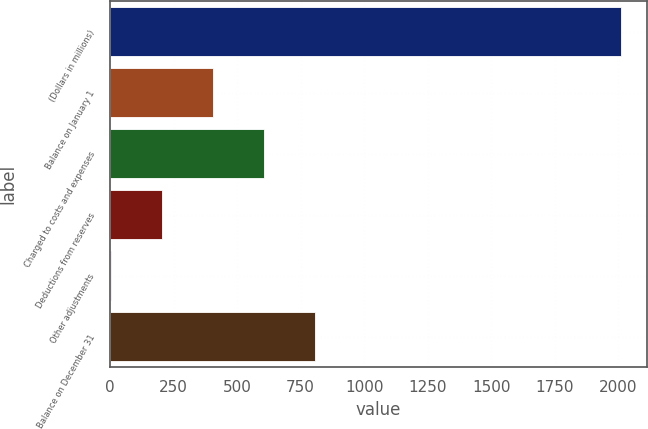Convert chart to OTSL. <chart><loc_0><loc_0><loc_500><loc_500><bar_chart><fcel>(Dollars in millions)<fcel>Balance on January 1<fcel>Charged to costs and expenses<fcel>Deductions from reserves<fcel>Other adjustments<fcel>Balance on December 31<nl><fcel>2012<fcel>404<fcel>605<fcel>203<fcel>2<fcel>806<nl></chart> 